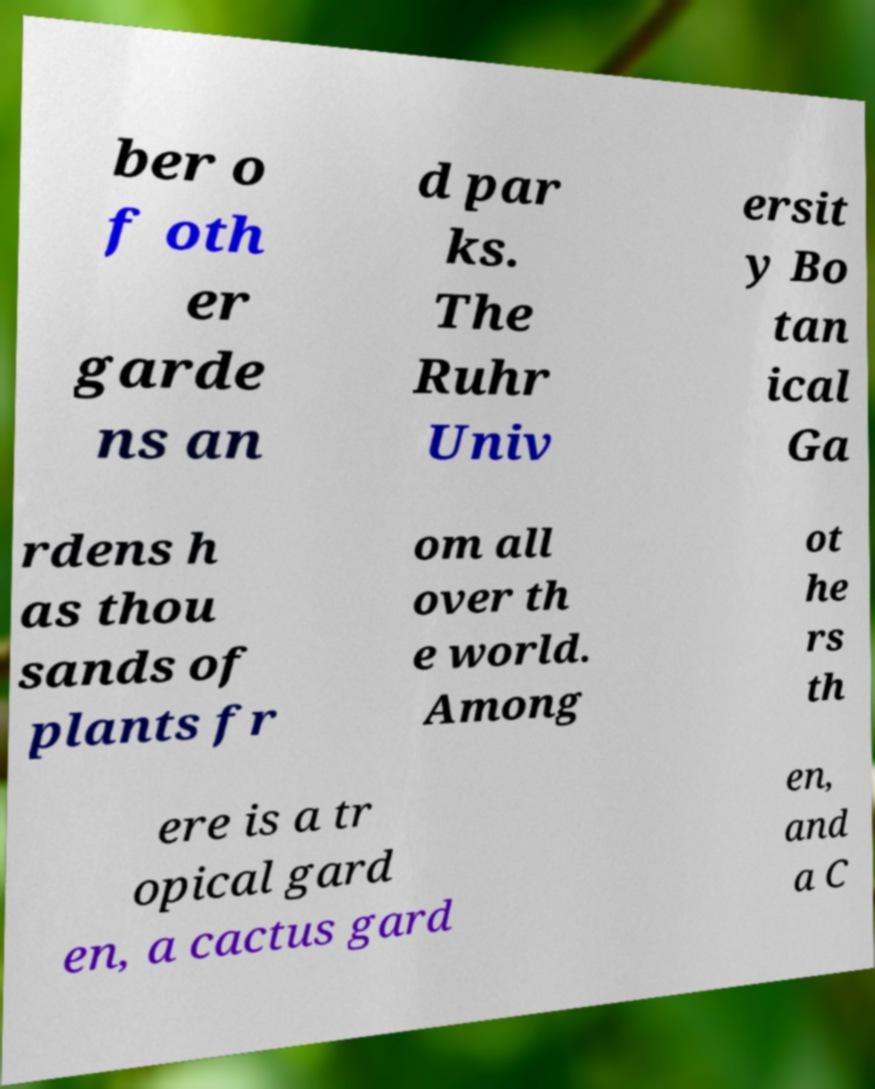Please identify and transcribe the text found in this image. ber o f oth er garde ns an d par ks. The Ruhr Univ ersit y Bo tan ical Ga rdens h as thou sands of plants fr om all over th e world. Among ot he rs th ere is a tr opical gard en, a cactus gard en, and a C 